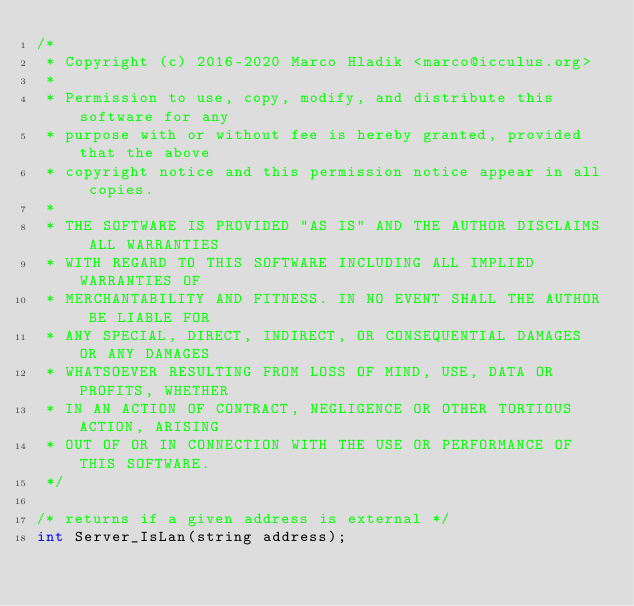Convert code to text. <code><loc_0><loc_0><loc_500><loc_500><_C_>/*
 * Copyright (c) 2016-2020 Marco Hladik <marco@icculus.org>
 *
 * Permission to use, copy, modify, and distribute this software for any
 * purpose with or without fee is hereby granted, provided that the above
 * copyright notice and this permission notice appear in all copies.
 *
 * THE SOFTWARE IS PROVIDED "AS IS" AND THE AUTHOR DISCLAIMS ALL WARRANTIES
 * WITH REGARD TO THIS SOFTWARE INCLUDING ALL IMPLIED WARRANTIES OF
 * MERCHANTABILITY AND FITNESS. IN NO EVENT SHALL THE AUTHOR BE LIABLE FOR
 * ANY SPECIAL, DIRECT, INDIRECT, OR CONSEQUENTIAL DAMAGES OR ANY DAMAGES
 * WHATSOEVER RESULTING FROM LOSS OF MIND, USE, DATA OR PROFITS, WHETHER
 * IN AN ACTION OF CONTRACT, NEGLIGENCE OR OTHER TORTIOUS ACTION, ARISING
 * OUT OF OR IN CONNECTION WITH THE USE OR PERFORMANCE OF THIS SOFTWARE.
 */

/* returns if a given address is external */
int Server_IsLan(string address);
</code> 